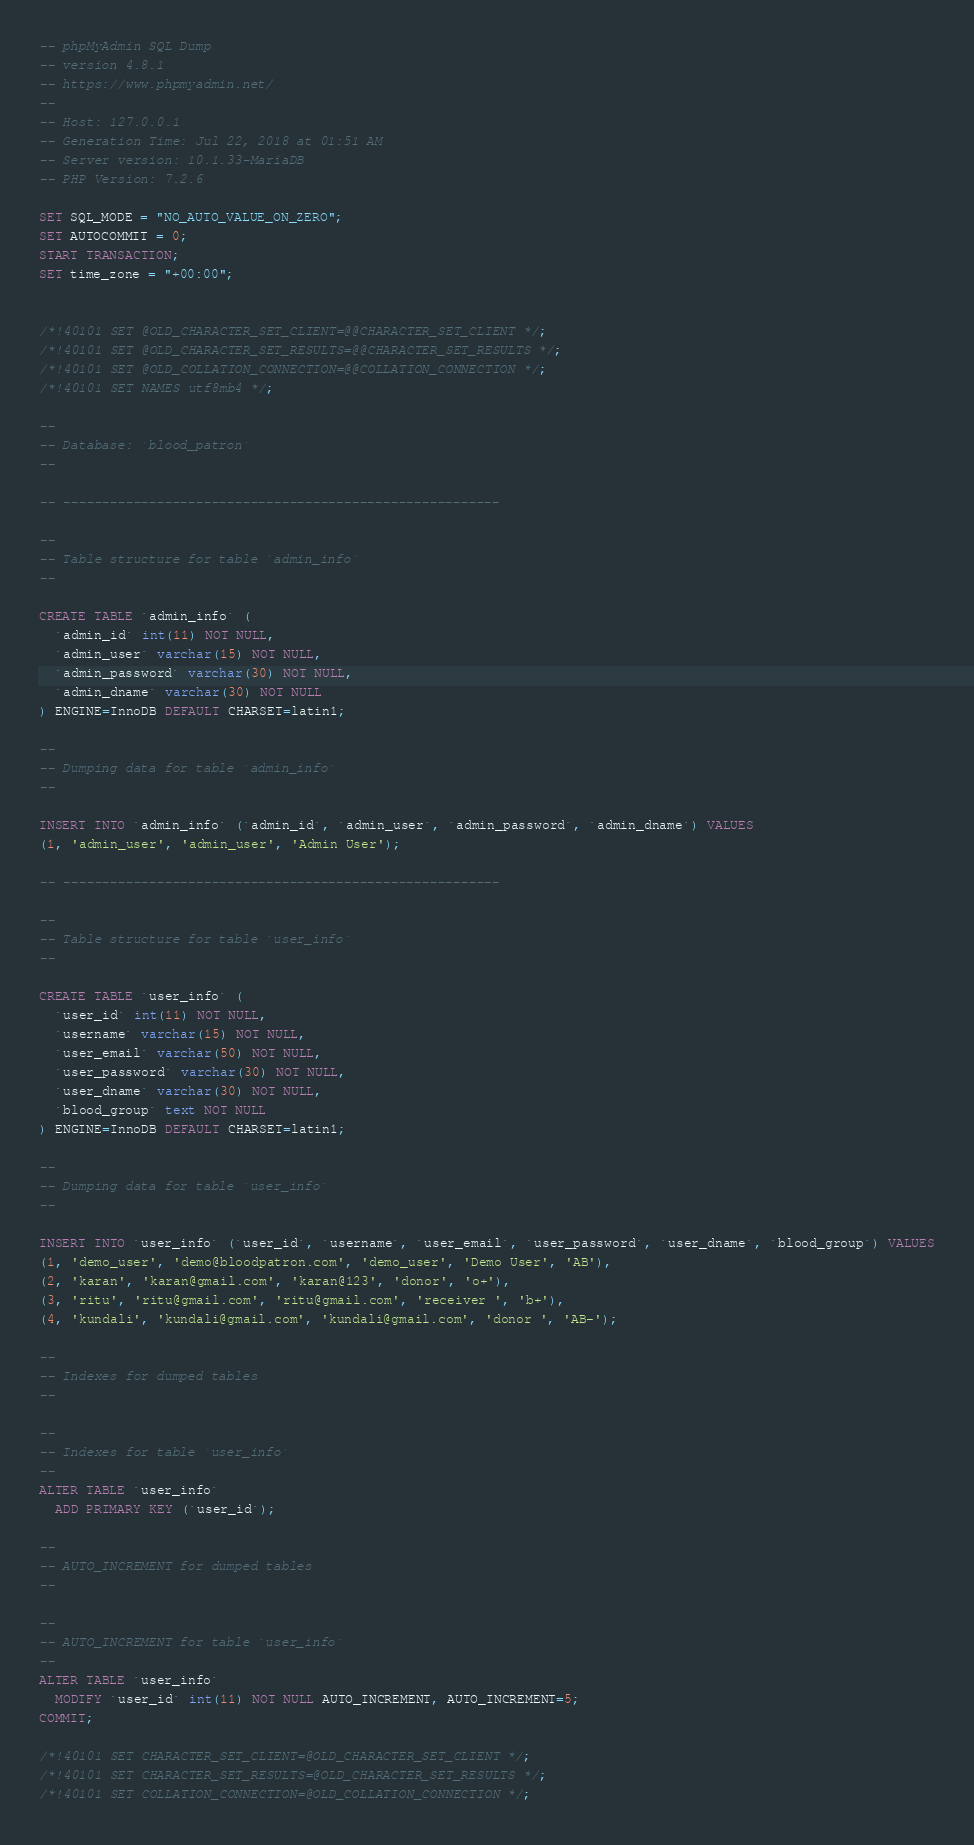<code> <loc_0><loc_0><loc_500><loc_500><_SQL_>-- phpMyAdmin SQL Dump
-- version 4.8.1
-- https://www.phpmyadmin.net/
--
-- Host: 127.0.0.1
-- Generation Time: Jul 22, 2018 at 01:51 AM
-- Server version: 10.1.33-MariaDB
-- PHP Version: 7.2.6

SET SQL_MODE = "NO_AUTO_VALUE_ON_ZERO";
SET AUTOCOMMIT = 0;
START TRANSACTION;
SET time_zone = "+00:00";


/*!40101 SET @OLD_CHARACTER_SET_CLIENT=@@CHARACTER_SET_CLIENT */;
/*!40101 SET @OLD_CHARACTER_SET_RESULTS=@@CHARACTER_SET_RESULTS */;
/*!40101 SET @OLD_COLLATION_CONNECTION=@@COLLATION_CONNECTION */;
/*!40101 SET NAMES utf8mb4 */;

--
-- Database: `blood_patron`
--

-- --------------------------------------------------------

--
-- Table structure for table `admin_info`
--

CREATE TABLE `admin_info` (
  `admin_id` int(11) NOT NULL,
  `admin_user` varchar(15) NOT NULL,
  `admin_password` varchar(30) NOT NULL,
  `admin_dname` varchar(30) NOT NULL
) ENGINE=InnoDB DEFAULT CHARSET=latin1;

--
-- Dumping data for table `admin_info`
--

INSERT INTO `admin_info` (`admin_id`, `admin_user`, `admin_password`, `admin_dname`) VALUES
(1, 'admin_user', 'admin_user', 'Admin User');

-- --------------------------------------------------------

--
-- Table structure for table `user_info`
--

CREATE TABLE `user_info` (
  `user_id` int(11) NOT NULL,
  `username` varchar(15) NOT NULL,
  `user_email` varchar(50) NOT NULL,
  `user_password` varchar(30) NOT NULL,
  `user_dname` varchar(30) NOT NULL,
  `blood_group` text NOT NULL
) ENGINE=InnoDB DEFAULT CHARSET=latin1;

--
-- Dumping data for table `user_info`
--

INSERT INTO `user_info` (`user_id`, `username`, `user_email`, `user_password`, `user_dname`, `blood_group`) VALUES
(1, 'demo_user', 'demo@bloodpatron.com', 'demo_user', 'Demo User', 'AB'),
(2, 'karan', 'karan@gmail.com', 'karan@123', 'donor', 'o+'),
(3, 'ritu', 'ritu@gmail.com', 'ritu@gmail.com', 'receiver ', 'b+'),
(4, 'kundali', 'kundali@gmail.com', 'kundali@gmail.com', 'donor ', 'AB-');

--
-- Indexes for dumped tables
--

--
-- Indexes for table `user_info`
--
ALTER TABLE `user_info`
  ADD PRIMARY KEY (`user_id`);

--
-- AUTO_INCREMENT for dumped tables
--

--
-- AUTO_INCREMENT for table `user_info`
--
ALTER TABLE `user_info`
  MODIFY `user_id` int(11) NOT NULL AUTO_INCREMENT, AUTO_INCREMENT=5;
COMMIT;

/*!40101 SET CHARACTER_SET_CLIENT=@OLD_CHARACTER_SET_CLIENT */;
/*!40101 SET CHARACTER_SET_RESULTS=@OLD_CHARACTER_SET_RESULTS */;
/*!40101 SET COLLATION_CONNECTION=@OLD_COLLATION_CONNECTION */;
</code> 